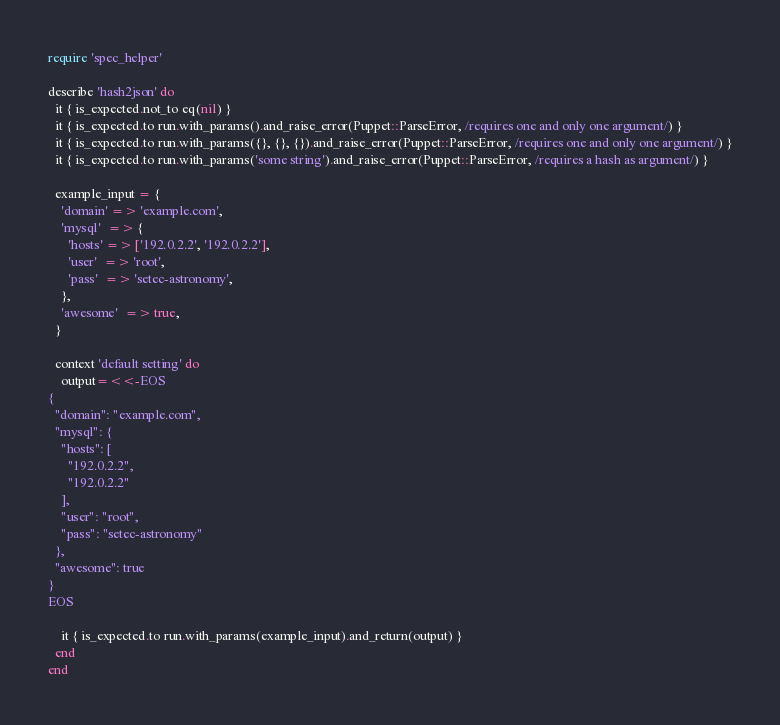<code> <loc_0><loc_0><loc_500><loc_500><_Ruby_>require 'spec_helper'

describe 'hash2json' do
  it { is_expected.not_to eq(nil) }
  it { is_expected.to run.with_params().and_raise_error(Puppet::ParseError, /requires one and only one argument/) }
  it { is_expected.to run.with_params({}, {}, {}).and_raise_error(Puppet::ParseError, /requires one and only one argument/) }
  it { is_expected.to run.with_params('some string').and_raise_error(Puppet::ParseError, /requires a hash as argument/) }

  example_input = {
    'domain' => 'example.com',
    'mysql'  => {
      'hosts' => ['192.0.2.2', '192.0.2.2'],
      'user'  => 'root',
      'pass'  => 'setec-astronomy',
    },
    'awesome'  => true,
  }

  context 'default setting' do
    output=<<-EOS
{
  "domain": "example.com",
  "mysql": {
    "hosts": [
      "192.0.2.2",
      "192.0.2.2"
    ],
    "user": "root",
    "pass": "setec-astronomy"
  },
  "awesome": true
}
EOS

    it { is_expected.to run.with_params(example_input).and_return(output) }
  end
end
</code> 